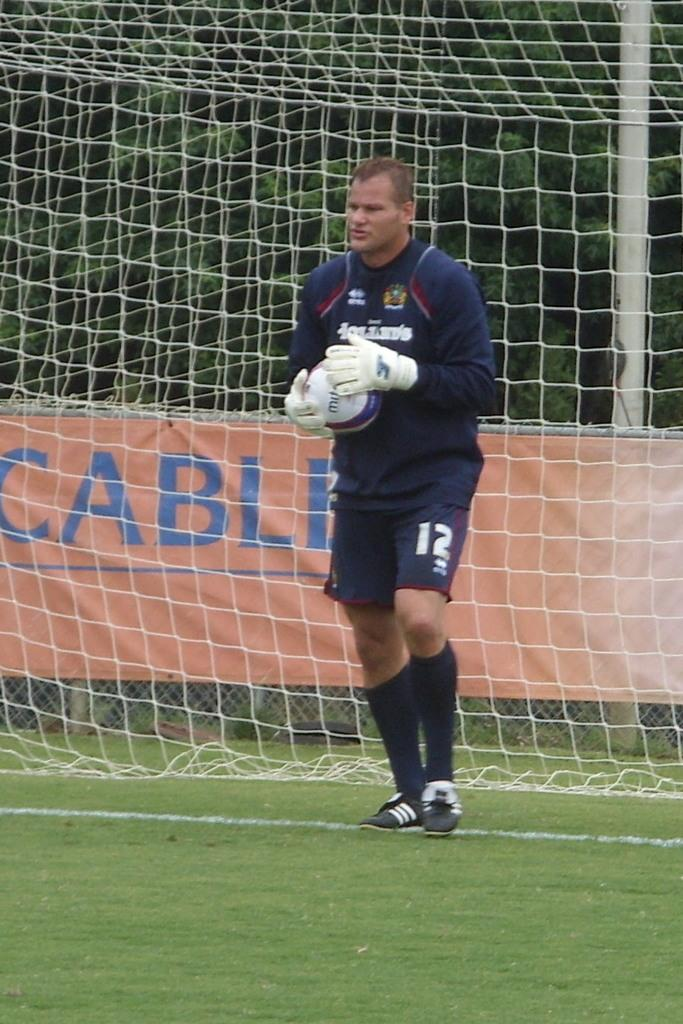Who is present in the image? There is a man in the image. What is the man holding in his hand? The man is holding a ball in his hand. What can be seen in the background of the image? There is a net and trees in the background of the image. Can you tell me how many kitties are playing with the goose in the image? There are no kitties or geese present in the image. What is the chance of winning a prize in the image? There is no indication of a prize or a game in the image. 